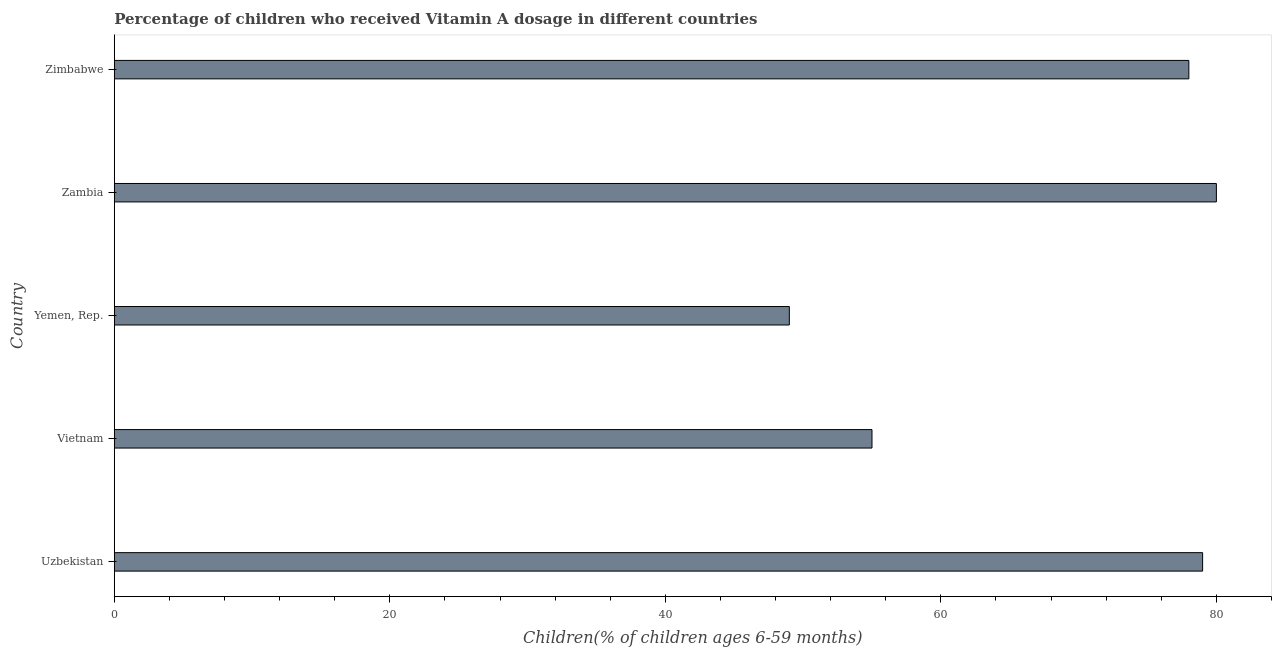Does the graph contain any zero values?
Provide a succinct answer. No. Does the graph contain grids?
Your answer should be compact. No. What is the title of the graph?
Give a very brief answer. Percentage of children who received Vitamin A dosage in different countries. What is the label or title of the X-axis?
Your response must be concise. Children(% of children ages 6-59 months). What is the label or title of the Y-axis?
Provide a short and direct response. Country. Across all countries, what is the maximum vitamin a supplementation coverage rate?
Provide a succinct answer. 80. In which country was the vitamin a supplementation coverage rate maximum?
Your answer should be compact. Zambia. In which country was the vitamin a supplementation coverage rate minimum?
Make the answer very short. Yemen, Rep. What is the sum of the vitamin a supplementation coverage rate?
Your answer should be very brief. 341. What is the average vitamin a supplementation coverage rate per country?
Offer a very short reply. 68.2. What is the median vitamin a supplementation coverage rate?
Offer a terse response. 78. What is the ratio of the vitamin a supplementation coverage rate in Uzbekistan to that in Yemen, Rep.?
Give a very brief answer. 1.61. What is the difference between the highest and the second highest vitamin a supplementation coverage rate?
Your answer should be very brief. 1. What is the difference between the highest and the lowest vitamin a supplementation coverage rate?
Keep it short and to the point. 31. How many bars are there?
Keep it short and to the point. 5. What is the difference between two consecutive major ticks on the X-axis?
Your answer should be compact. 20. What is the Children(% of children ages 6-59 months) in Uzbekistan?
Keep it short and to the point. 79. What is the Children(% of children ages 6-59 months) in Vietnam?
Your answer should be very brief. 55. What is the Children(% of children ages 6-59 months) in Yemen, Rep.?
Your response must be concise. 49. What is the Children(% of children ages 6-59 months) of Zambia?
Make the answer very short. 80. What is the Children(% of children ages 6-59 months) of Zimbabwe?
Give a very brief answer. 78. What is the difference between the Children(% of children ages 6-59 months) in Uzbekistan and Vietnam?
Your answer should be very brief. 24. What is the difference between the Children(% of children ages 6-59 months) in Uzbekistan and Yemen, Rep.?
Keep it short and to the point. 30. What is the difference between the Children(% of children ages 6-59 months) in Uzbekistan and Zimbabwe?
Your answer should be very brief. 1. What is the difference between the Children(% of children ages 6-59 months) in Vietnam and Zambia?
Give a very brief answer. -25. What is the difference between the Children(% of children ages 6-59 months) in Vietnam and Zimbabwe?
Provide a succinct answer. -23. What is the difference between the Children(% of children ages 6-59 months) in Yemen, Rep. and Zambia?
Provide a short and direct response. -31. What is the ratio of the Children(% of children ages 6-59 months) in Uzbekistan to that in Vietnam?
Offer a terse response. 1.44. What is the ratio of the Children(% of children ages 6-59 months) in Uzbekistan to that in Yemen, Rep.?
Keep it short and to the point. 1.61. What is the ratio of the Children(% of children ages 6-59 months) in Uzbekistan to that in Zimbabwe?
Offer a terse response. 1.01. What is the ratio of the Children(% of children ages 6-59 months) in Vietnam to that in Yemen, Rep.?
Offer a very short reply. 1.12. What is the ratio of the Children(% of children ages 6-59 months) in Vietnam to that in Zambia?
Your response must be concise. 0.69. What is the ratio of the Children(% of children ages 6-59 months) in Vietnam to that in Zimbabwe?
Your answer should be very brief. 0.7. What is the ratio of the Children(% of children ages 6-59 months) in Yemen, Rep. to that in Zambia?
Make the answer very short. 0.61. What is the ratio of the Children(% of children ages 6-59 months) in Yemen, Rep. to that in Zimbabwe?
Make the answer very short. 0.63. What is the ratio of the Children(% of children ages 6-59 months) in Zambia to that in Zimbabwe?
Offer a very short reply. 1.03. 